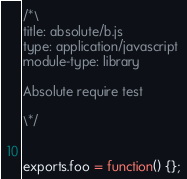Convert code to text. <code><loc_0><loc_0><loc_500><loc_500><_JavaScript_>/*\
title: absolute/b.js
type: application/javascript
module-type: library

Absolute require test

\*/


exports.foo = function() {};
</code> 